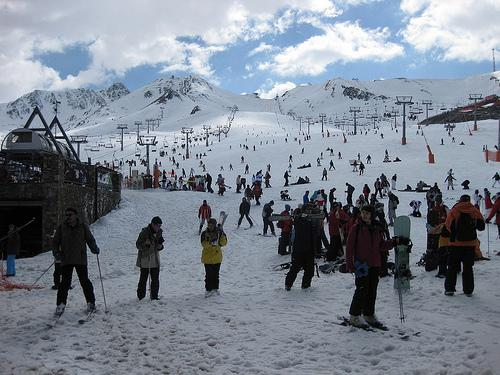Mention five different objects or elements seen in the image. White clouds, blue sky, snow-covered field, skiers, and snowboarders. Briefly describe the landscape in the image. A snow-covered mountain with white clouds in a blue sky, a snowy field, and a train in the background. List three different colors of clothing worn by the people in the image. Orange, yellow, and blue. Find a person with a distinctive clothing item and describe them. A man wearing an orange coat and a backpack is skiing on the hill. Provide a brief overview of the activities taking place in the image. Skiers and snowboarders are enjoying a day on a snowy mountain slope, while others hold skis and poles, all under a sky with white clouds. Select any person from the image and describe their outfit. There is a person wearing a yellow jacket and black pants, holding ski poles and standing on white skis. Identify the most prominent feature in the image. Many people skiing and snowboarding on a snow covered mountain with white clouds in the blue sky above. What activity are the majority of people in the image involved in? The majority of people are skiing or snowboarding on the snow-covered mountain. Explain what some people on the image are wearing. There are people wearing orange and yellow jackets, black pants, blue pants, and dark gloves, some with backpacks and ski poles. In the image, are there any clouds? Yes, there are white clouds in the blue sky. 